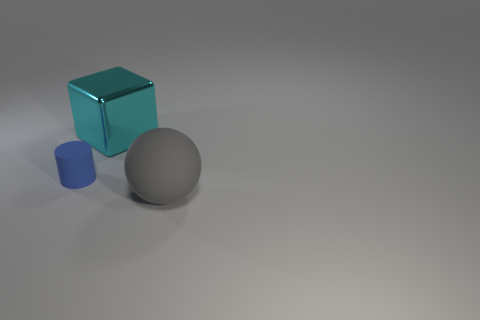Add 2 small blue cylinders. How many objects exist? 5 Subtract all cylinders. How many objects are left? 2 Add 3 large blocks. How many large blocks are left? 4 Add 3 purple balls. How many purple balls exist? 3 Subtract 0 blue spheres. How many objects are left? 3 Subtract all large shiny things. Subtract all gray matte things. How many objects are left? 1 